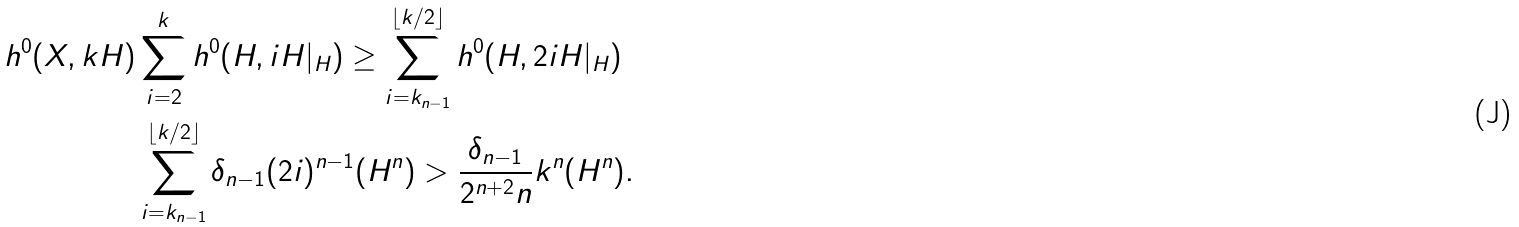<formula> <loc_0><loc_0><loc_500><loc_500>h ^ { 0 } ( X , k H ) & \sum _ { i = 2 } ^ { k } h ^ { 0 } ( H , i H | _ { H } ) \geq \sum _ { i = k _ { n - 1 } } ^ { \lfloor k / 2 \rfloor } h ^ { 0 } ( H , 2 i H | _ { H } ) \\ & \sum _ { i = k _ { n - 1 } } ^ { \lfloor k / 2 \rfloor } \delta _ { n - 1 } ( 2 i ) ^ { n - 1 } ( H ^ { n } ) > \frac { \delta _ { n - 1 } } { 2 ^ { n + 2 } n } k ^ { n } ( H ^ { n } ) .</formula> 